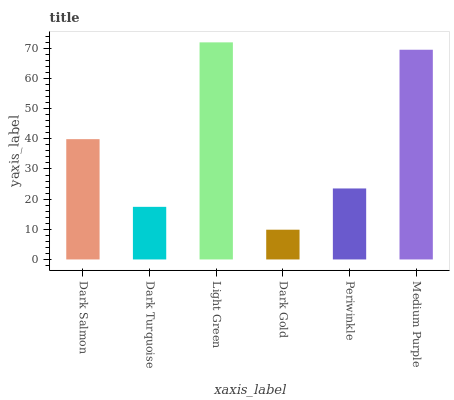Is Dark Turquoise the minimum?
Answer yes or no. No. Is Dark Turquoise the maximum?
Answer yes or no. No. Is Dark Salmon greater than Dark Turquoise?
Answer yes or no. Yes. Is Dark Turquoise less than Dark Salmon?
Answer yes or no. Yes. Is Dark Turquoise greater than Dark Salmon?
Answer yes or no. No. Is Dark Salmon less than Dark Turquoise?
Answer yes or no. No. Is Dark Salmon the high median?
Answer yes or no. Yes. Is Periwinkle the low median?
Answer yes or no. Yes. Is Dark Gold the high median?
Answer yes or no. No. Is Medium Purple the low median?
Answer yes or no. No. 